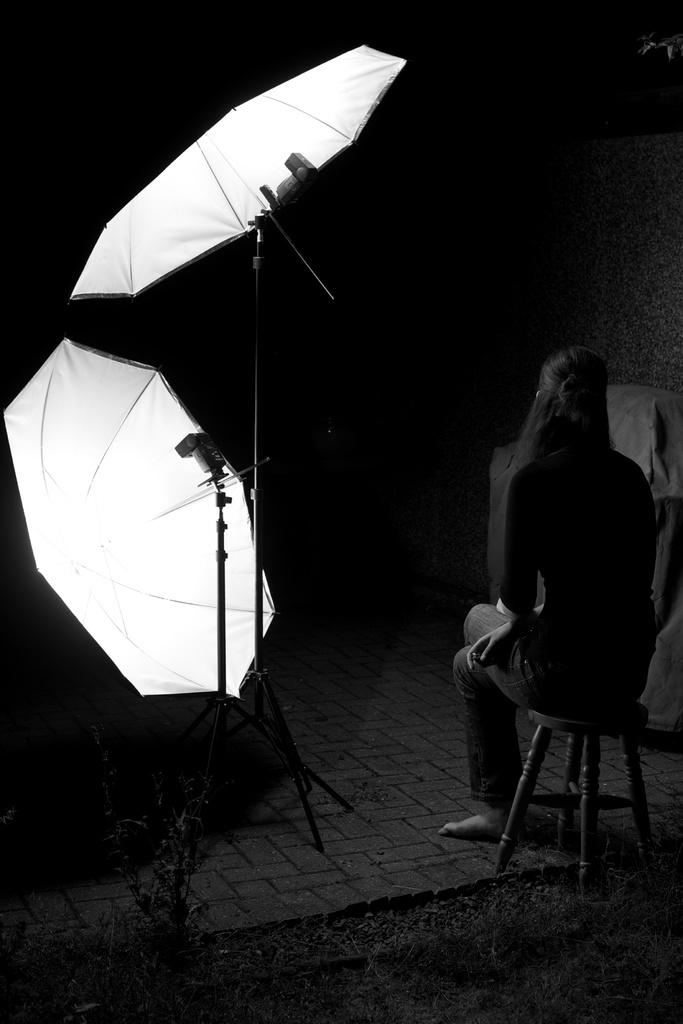What objects are present in the image? There are umbrellas in the image. What is the woman in the image doing? The woman is sitting on a stool in the image. Where is the woman located in the image? The woman is on the right side of the image. What can be observed about the background of the image? The background of the image is dark. What type of tomatoes can be seen growing in space in the image? There is no reference to tomatoes or space in the image; it features umbrellas and a woman sitting on a stool. Can you identify the actor who is holding the umbrella in the image? There is no actor present in the image, only a woman sitting on a stool. 